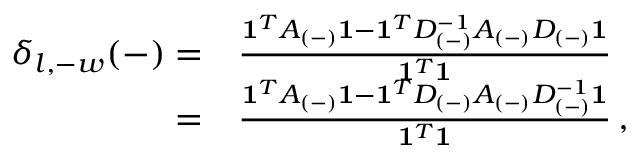<formula> <loc_0><loc_0><loc_500><loc_500>\begin{array} { r l } { \delta _ { l , - w } ( - ) = } & \frac { 1 ^ { T } A _ { ( - ) } 1 - 1 ^ { T } D _ { ( - ) } ^ { - 1 } A _ { ( - ) } D _ { ( - ) } 1 } { 1 ^ { T } 1 } } \\ { = } & \frac { 1 ^ { T } A _ { ( - ) } 1 - 1 ^ { T } D _ { ( - ) } A _ { ( - ) } D _ { ( - ) } ^ { - 1 } 1 } { 1 ^ { T } 1 } \, , } \end{array}</formula> 